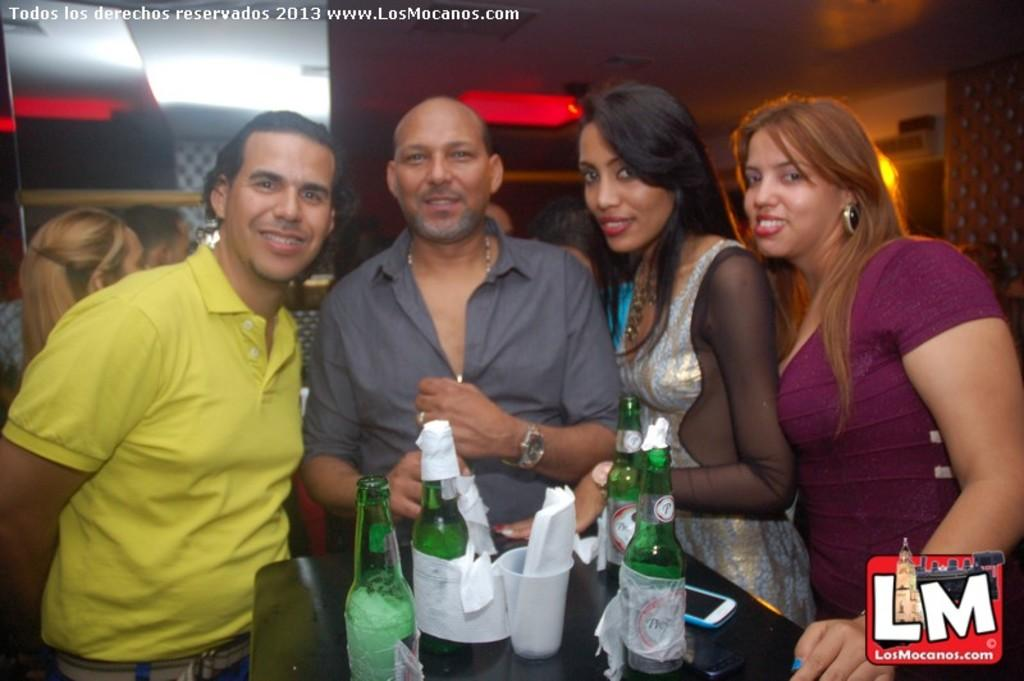How many people are in the image? There are four persons standing in the image. What are the persons doing in the image? The persons are giving stills. What is in front of the persons? There is a table in front of the persons. What objects can be seen on the table? There are bottles, a cup, papers, and a mobile on the table. Is there a yard visible in the image? There is no yard visible in the image; it appears to be an indoor setting. Are there any nails being used by the persons in the image? There is no indication of nails or any related activity in the image. 